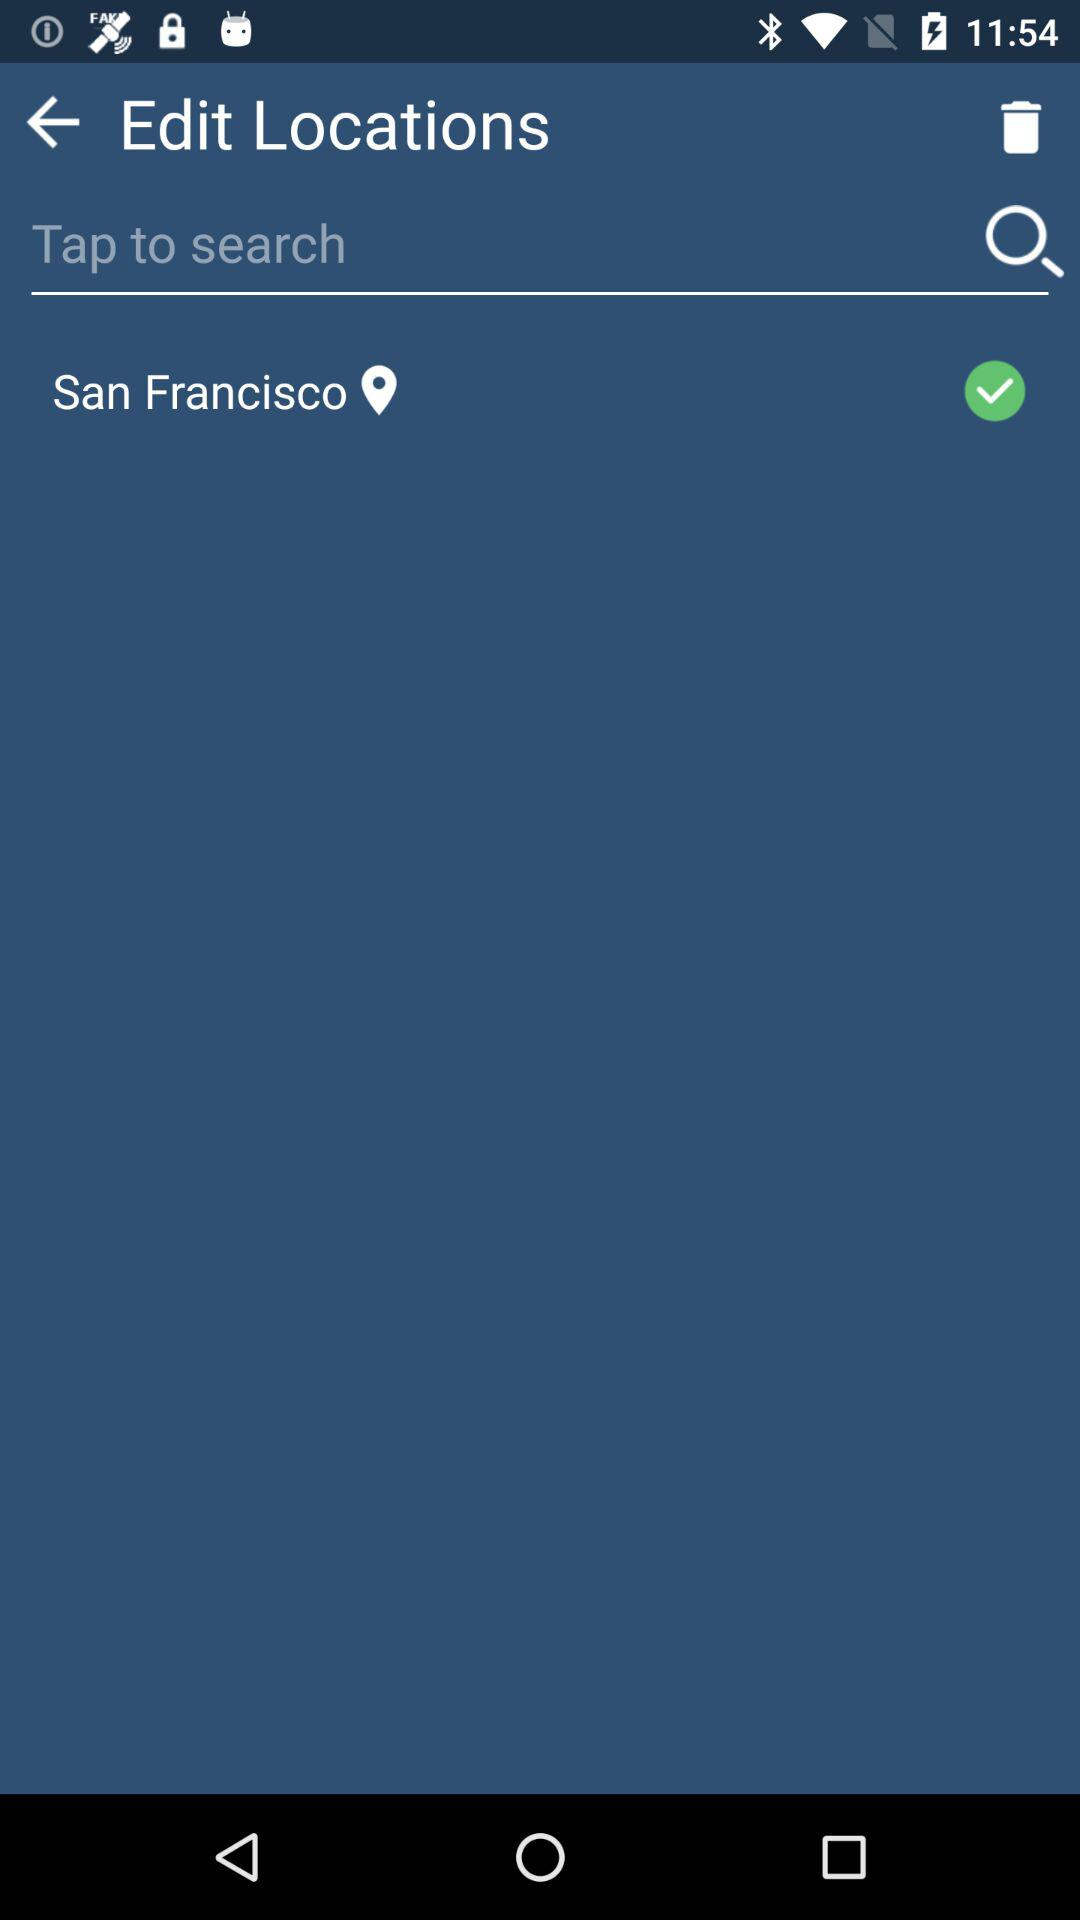What is the location? The location is San Francisco. 